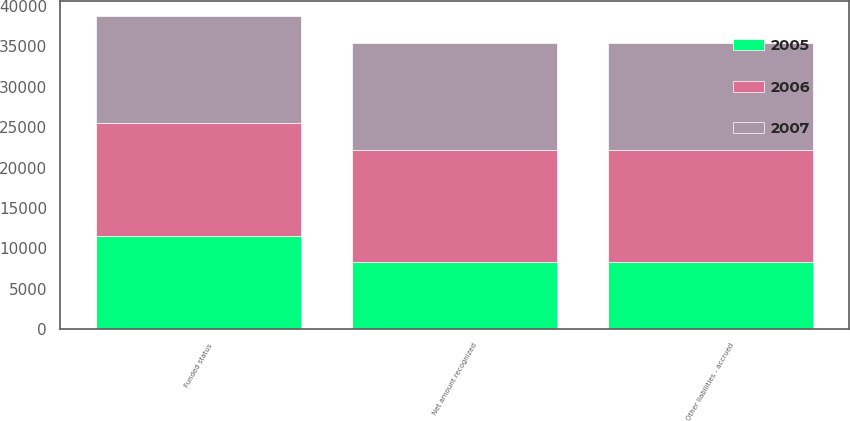<chart> <loc_0><loc_0><loc_500><loc_500><stacked_bar_chart><ecel><fcel>Funded status<fcel>Net amount recognized<fcel>Other liabilities - accrued<nl><fcel>2007<fcel>13224<fcel>13224<fcel>13224<nl><fcel>2006<fcel>13900<fcel>13900<fcel>13900<nl><fcel>2005<fcel>11569<fcel>8329<fcel>8329<nl></chart> 